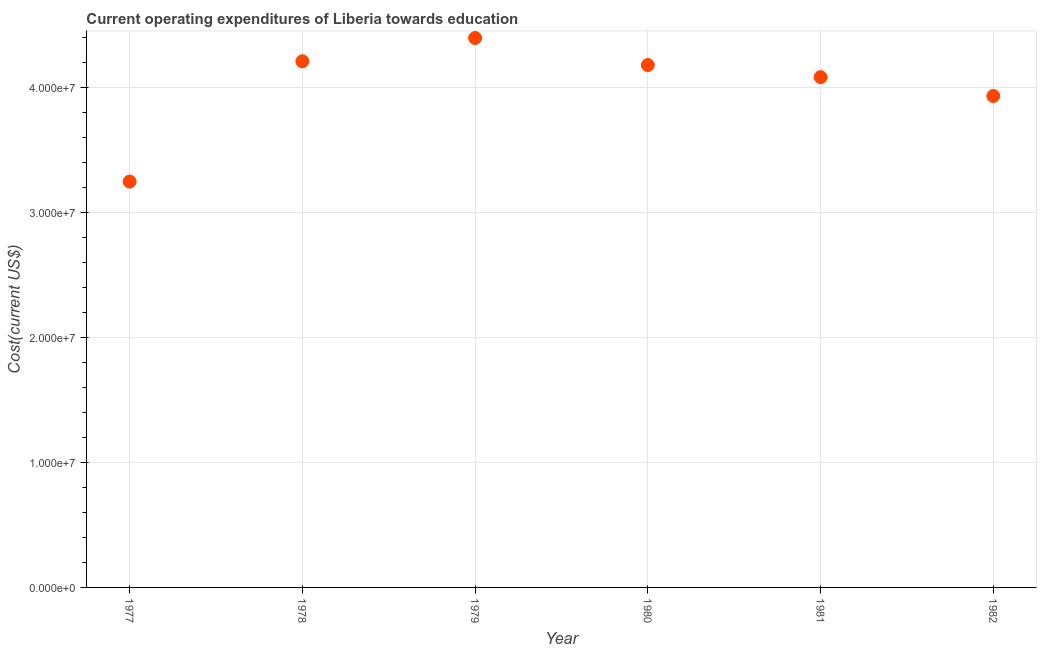What is the education expenditure in 1977?
Offer a very short reply. 3.25e+07. Across all years, what is the maximum education expenditure?
Your response must be concise. 4.40e+07. Across all years, what is the minimum education expenditure?
Your response must be concise. 3.25e+07. In which year was the education expenditure maximum?
Provide a succinct answer. 1979. In which year was the education expenditure minimum?
Make the answer very short. 1977. What is the sum of the education expenditure?
Your answer should be compact. 2.41e+08. What is the difference between the education expenditure in 1977 and 1978?
Keep it short and to the point. -9.63e+06. What is the average education expenditure per year?
Provide a succinct answer. 4.01e+07. What is the median education expenditure?
Give a very brief answer. 4.13e+07. What is the ratio of the education expenditure in 1977 to that in 1981?
Keep it short and to the point. 0.8. Is the education expenditure in 1977 less than that in 1981?
Make the answer very short. Yes. Is the difference between the education expenditure in 1980 and 1981 greater than the difference between any two years?
Your response must be concise. No. What is the difference between the highest and the second highest education expenditure?
Give a very brief answer. 1.86e+06. What is the difference between the highest and the lowest education expenditure?
Keep it short and to the point. 1.15e+07. In how many years, is the education expenditure greater than the average education expenditure taken over all years?
Give a very brief answer. 4. What is the difference between two consecutive major ticks on the Y-axis?
Your answer should be compact. 1.00e+07. Are the values on the major ticks of Y-axis written in scientific E-notation?
Keep it short and to the point. Yes. Does the graph contain grids?
Make the answer very short. Yes. What is the title of the graph?
Provide a succinct answer. Current operating expenditures of Liberia towards education. What is the label or title of the Y-axis?
Offer a terse response. Cost(current US$). What is the Cost(current US$) in 1977?
Keep it short and to the point. 3.25e+07. What is the Cost(current US$) in 1978?
Your answer should be very brief. 4.21e+07. What is the Cost(current US$) in 1979?
Provide a short and direct response. 4.40e+07. What is the Cost(current US$) in 1980?
Provide a succinct answer. 4.18e+07. What is the Cost(current US$) in 1981?
Your answer should be very brief. 4.09e+07. What is the Cost(current US$) in 1982?
Your answer should be compact. 3.94e+07. What is the difference between the Cost(current US$) in 1977 and 1978?
Offer a very short reply. -9.63e+06. What is the difference between the Cost(current US$) in 1977 and 1979?
Offer a terse response. -1.15e+07. What is the difference between the Cost(current US$) in 1977 and 1980?
Make the answer very short. -9.33e+06. What is the difference between the Cost(current US$) in 1977 and 1981?
Your response must be concise. -8.36e+06. What is the difference between the Cost(current US$) in 1977 and 1982?
Make the answer very short. -6.85e+06. What is the difference between the Cost(current US$) in 1978 and 1979?
Your answer should be very brief. -1.86e+06. What is the difference between the Cost(current US$) in 1978 and 1980?
Your answer should be very brief. 3.02e+05. What is the difference between the Cost(current US$) in 1978 and 1981?
Your answer should be very brief. 1.27e+06. What is the difference between the Cost(current US$) in 1978 and 1982?
Provide a succinct answer. 2.78e+06. What is the difference between the Cost(current US$) in 1979 and 1980?
Offer a terse response. 2.16e+06. What is the difference between the Cost(current US$) in 1979 and 1981?
Your response must be concise. 3.13e+06. What is the difference between the Cost(current US$) in 1979 and 1982?
Give a very brief answer. 4.64e+06. What is the difference between the Cost(current US$) in 1980 and 1981?
Offer a terse response. 9.69e+05. What is the difference between the Cost(current US$) in 1980 and 1982?
Make the answer very short. 2.48e+06. What is the difference between the Cost(current US$) in 1981 and 1982?
Your answer should be very brief. 1.51e+06. What is the ratio of the Cost(current US$) in 1977 to that in 1978?
Your answer should be very brief. 0.77. What is the ratio of the Cost(current US$) in 1977 to that in 1979?
Ensure brevity in your answer.  0.74. What is the ratio of the Cost(current US$) in 1977 to that in 1980?
Make the answer very short. 0.78. What is the ratio of the Cost(current US$) in 1977 to that in 1981?
Provide a short and direct response. 0.8. What is the ratio of the Cost(current US$) in 1977 to that in 1982?
Provide a short and direct response. 0.83. What is the ratio of the Cost(current US$) in 1978 to that in 1979?
Provide a succinct answer. 0.96. What is the ratio of the Cost(current US$) in 1978 to that in 1980?
Your answer should be compact. 1.01. What is the ratio of the Cost(current US$) in 1978 to that in 1981?
Your answer should be very brief. 1.03. What is the ratio of the Cost(current US$) in 1978 to that in 1982?
Make the answer very short. 1.07. What is the ratio of the Cost(current US$) in 1979 to that in 1980?
Give a very brief answer. 1.05. What is the ratio of the Cost(current US$) in 1979 to that in 1981?
Your answer should be compact. 1.08. What is the ratio of the Cost(current US$) in 1979 to that in 1982?
Offer a very short reply. 1.12. What is the ratio of the Cost(current US$) in 1980 to that in 1981?
Your response must be concise. 1.02. What is the ratio of the Cost(current US$) in 1980 to that in 1982?
Your answer should be compact. 1.06. What is the ratio of the Cost(current US$) in 1981 to that in 1982?
Keep it short and to the point. 1.04. 